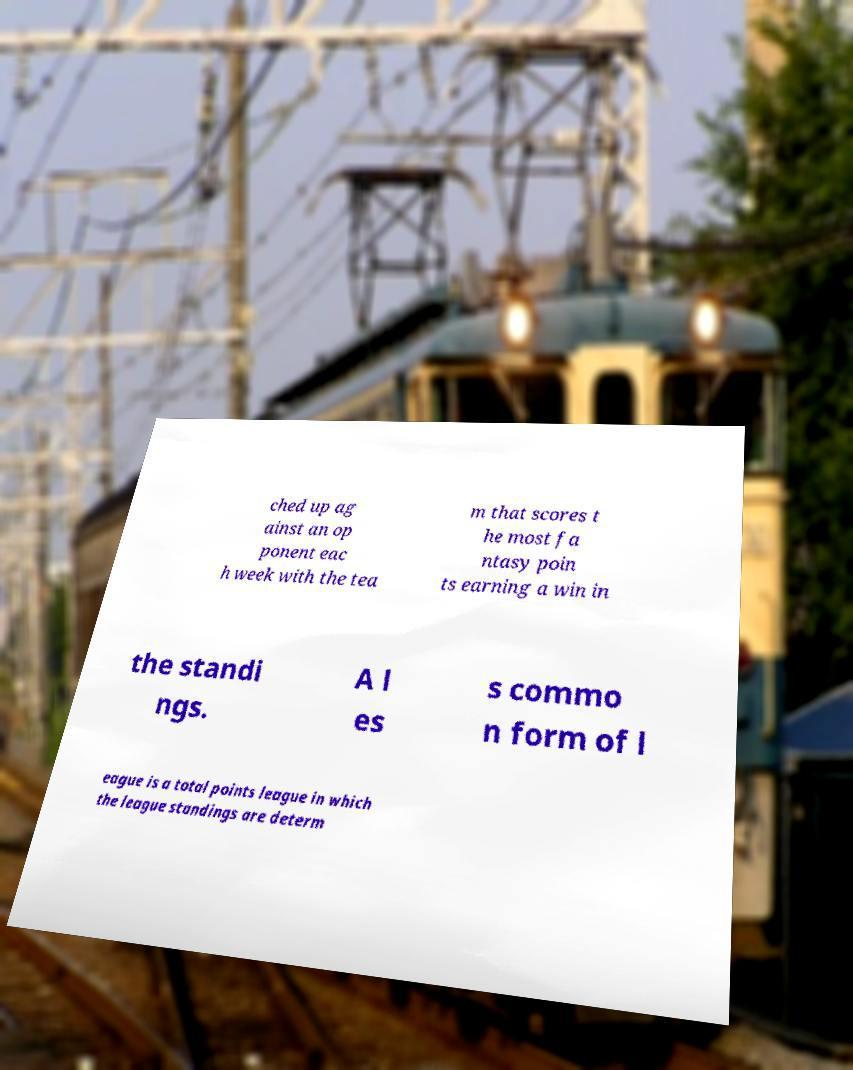I need the written content from this picture converted into text. Can you do that? ched up ag ainst an op ponent eac h week with the tea m that scores t he most fa ntasy poin ts earning a win in the standi ngs. A l es s commo n form of l eague is a total points league in which the league standings are determ 